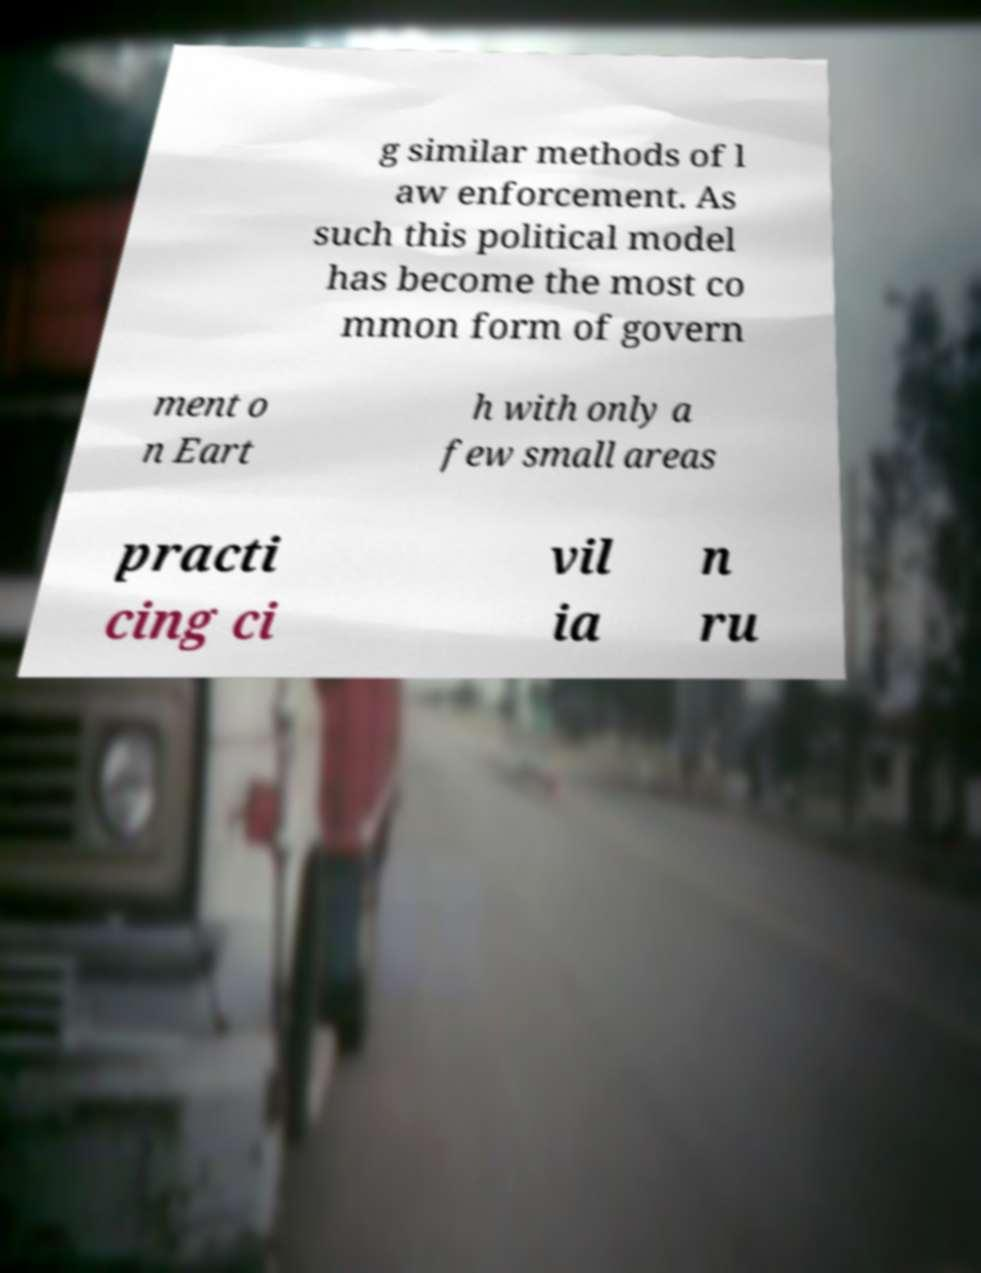Could you extract and type out the text from this image? g similar methods of l aw enforcement. As such this political model has become the most co mmon form of govern ment o n Eart h with only a few small areas practi cing ci vil ia n ru 